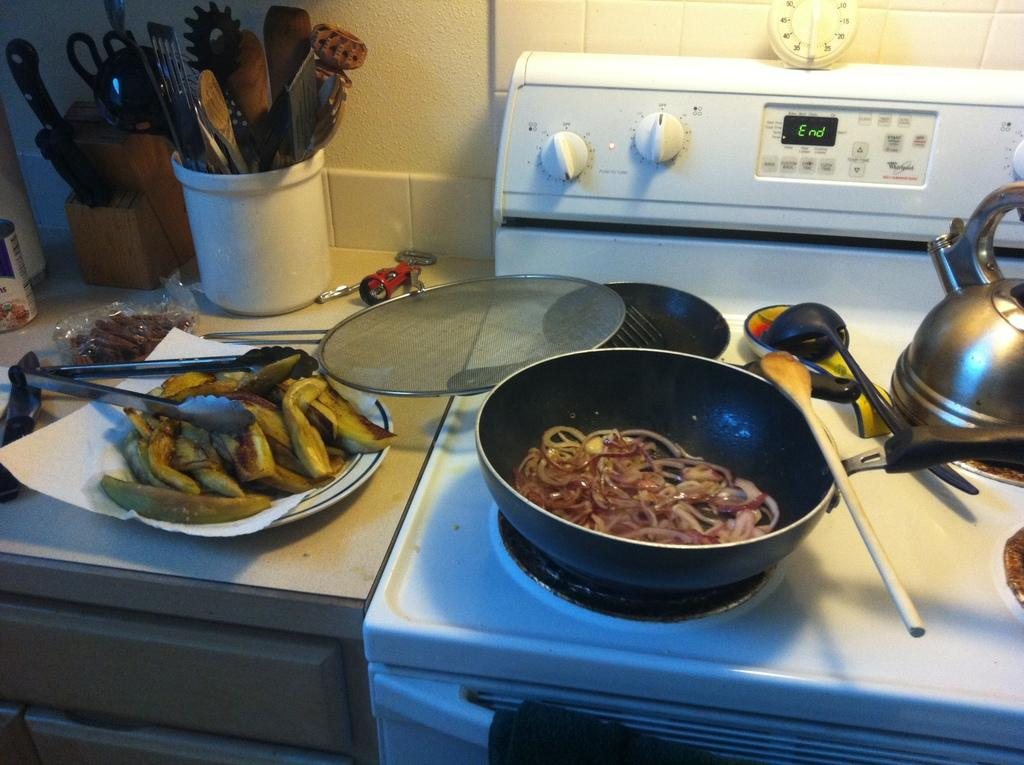Provide a one-sentence caption for the provided image. The display of a white oven reads "End," with a pan of food on top of it. 